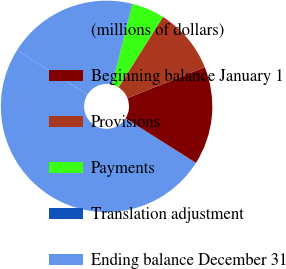Convert chart to OTSL. <chart><loc_0><loc_0><loc_500><loc_500><pie_chart><fcel>(millions of dollars)<fcel>Beginning balance January 1<fcel>Provisions<fcel>Payments<fcel>Translation adjustment<fcel>Ending balance December 31<nl><fcel>49.93%<fcel>15.0%<fcel>10.01%<fcel>5.02%<fcel>0.03%<fcel>19.99%<nl></chart> 